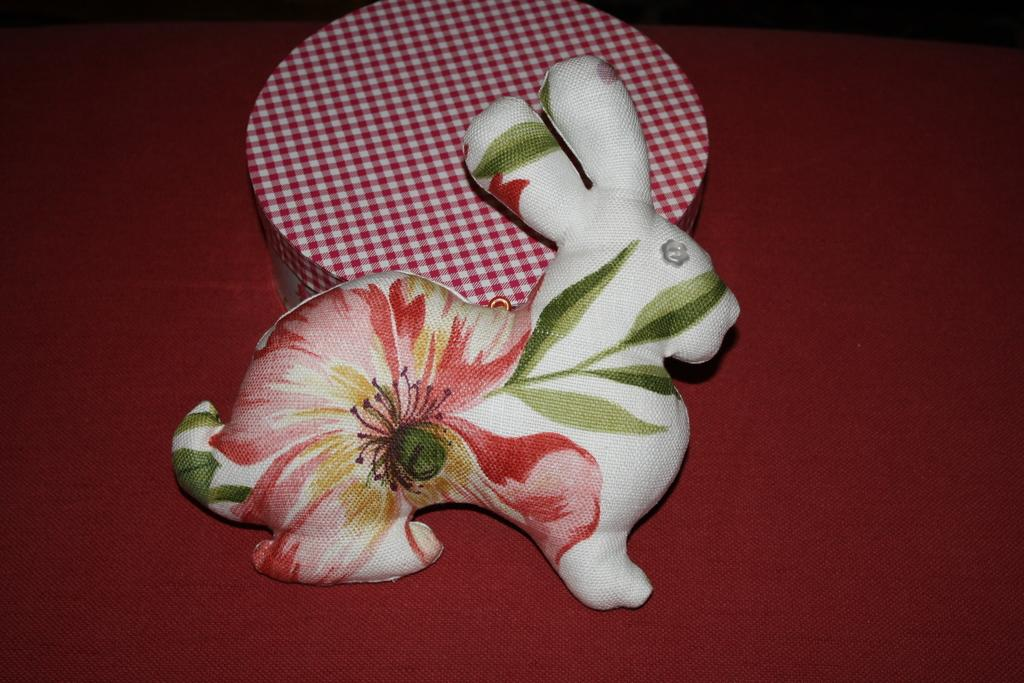What is the main object in the picture? There is a toy in the picture. What material is the toy made of? The toy is made of cloth. What is the toy placed on? The toy is placed on a red cloth. How many boys are holding the pan in the image? There is no pan or boys present in the image. 